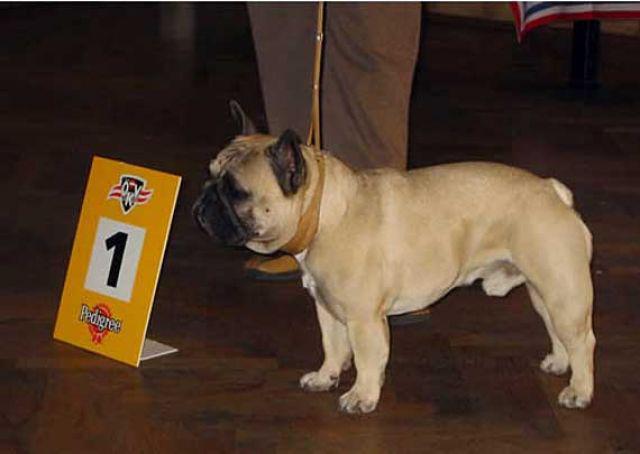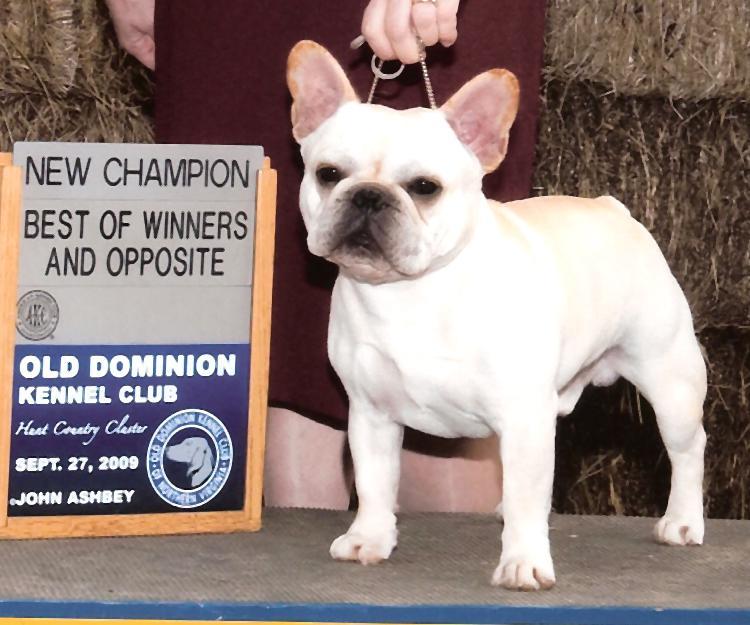The first image is the image on the left, the second image is the image on the right. Given the left and right images, does the statement "The left image features one standing buff-beige bulldog, and the right image contains one standing white bulldog who is gazing at the camera." hold true? Answer yes or no. Yes. The first image is the image on the left, the second image is the image on the right. For the images shown, is this caption "Two French Bulldogs are being held on a leash by a human." true? Answer yes or no. Yes. 